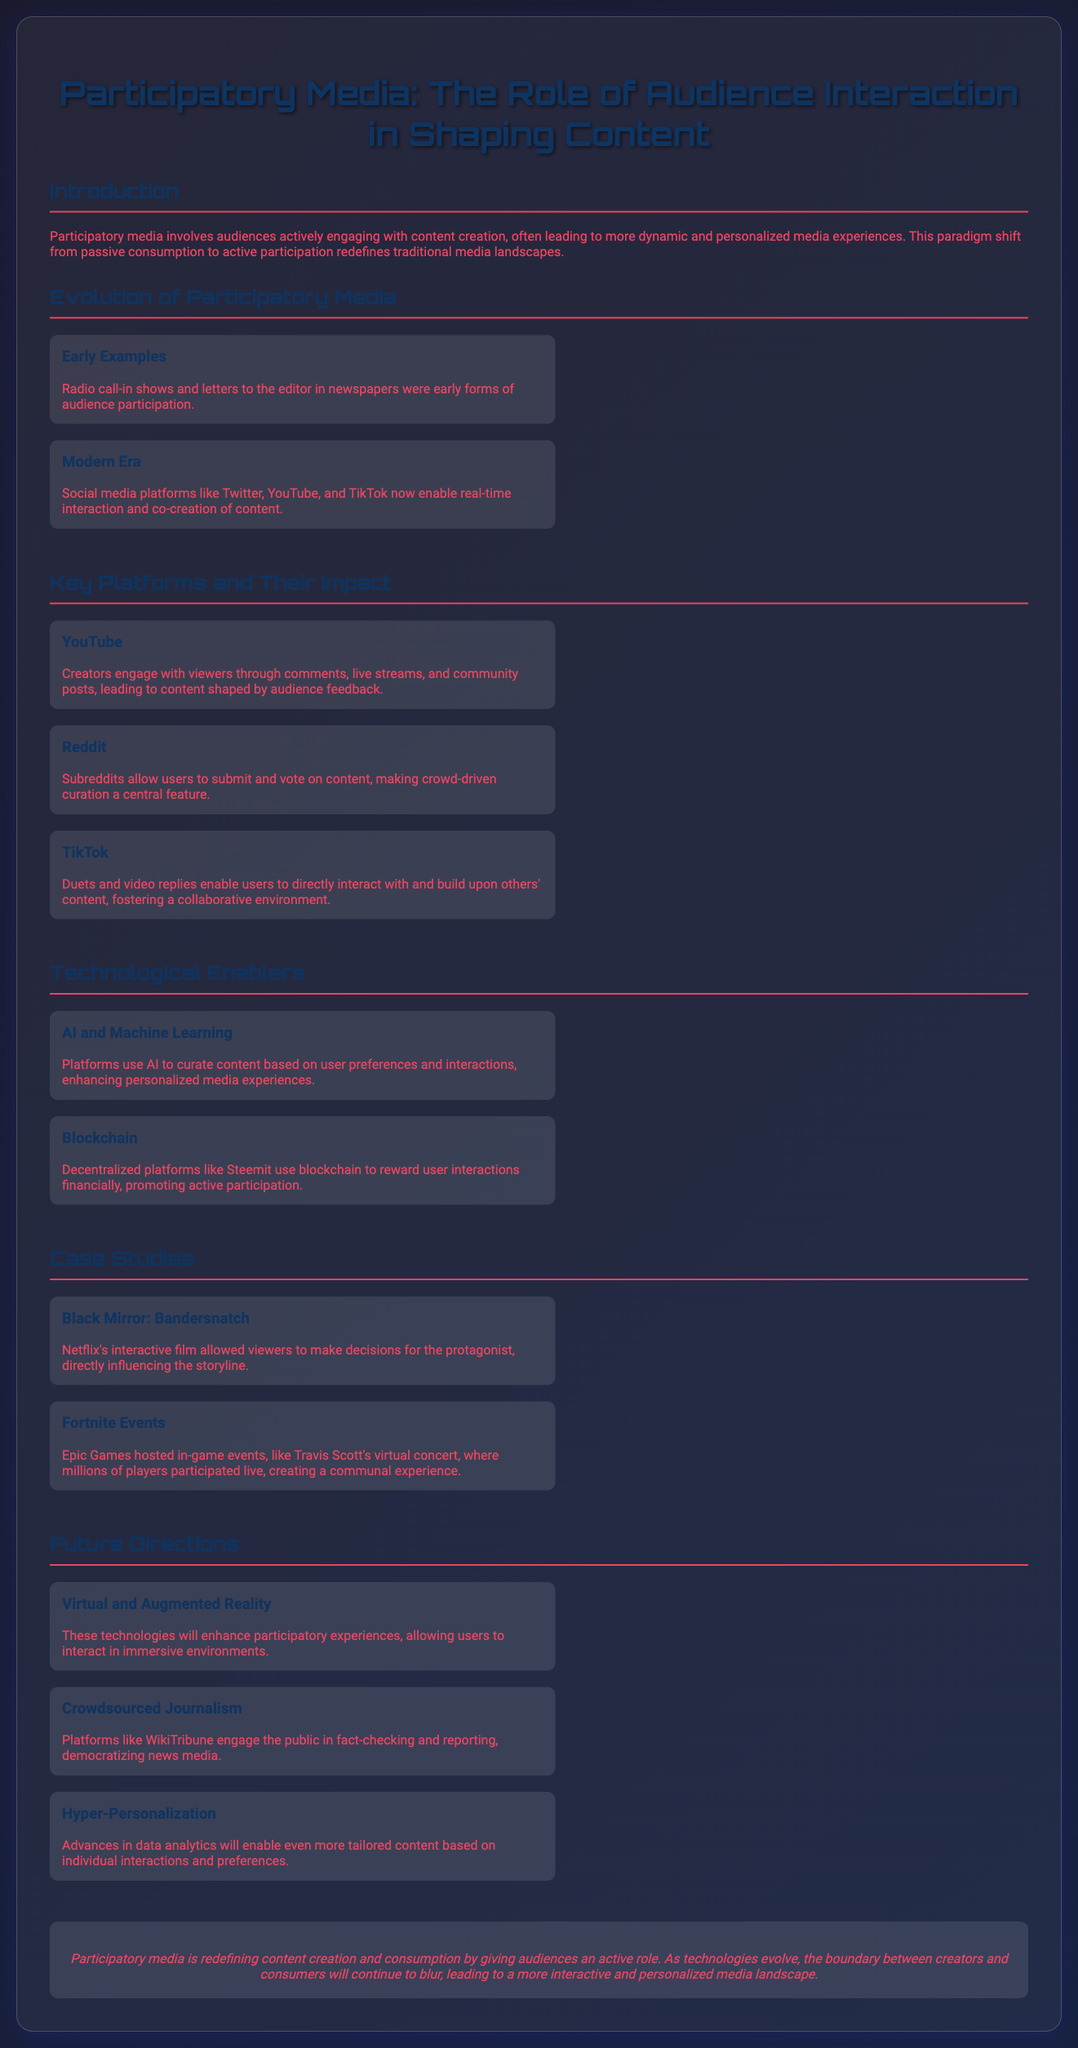What is the title of the presentation? The title of the presentation is explicitly stated at the top of the document.
Answer: Participatory Media: The Role of Audience Interaction in Shaping Content Which platforms allow real-time audience interaction? The section discusses modern platforms that facilitate immediate audience engagement and participation.
Answer: Twitter, YouTube, and TikTok What technology is used to enhance personalized media experiences? The document mentions technological enablers that contribute to creating tailored content for users.
Answer: AI and Machine Learning What is an example of early participatory media? The presentation lists historical methods of audience interaction that preceded modern platforms.
Answer: Radio call-in shows In which case study does the audience influence the storyline? Case studies provided illustrate unique participatory media examples where audience choices affect outcomes.
Answer: Black Mirror: Bandersnatch What future direction is mentioned for participatory media? The future direction section outlines innovations that will shape audience interaction moving forward.
Answer: Virtual and Augmented Reality What is the main conclusion of the presentation? The conclusion summarizes the overarching theme and outcome of participatory media's evolution.
Answer: Participatory media is redefining content creation and consumption by giving audiences an active role 